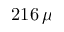<formula> <loc_0><loc_0><loc_500><loc_500>2 1 6 \, \mu</formula> 